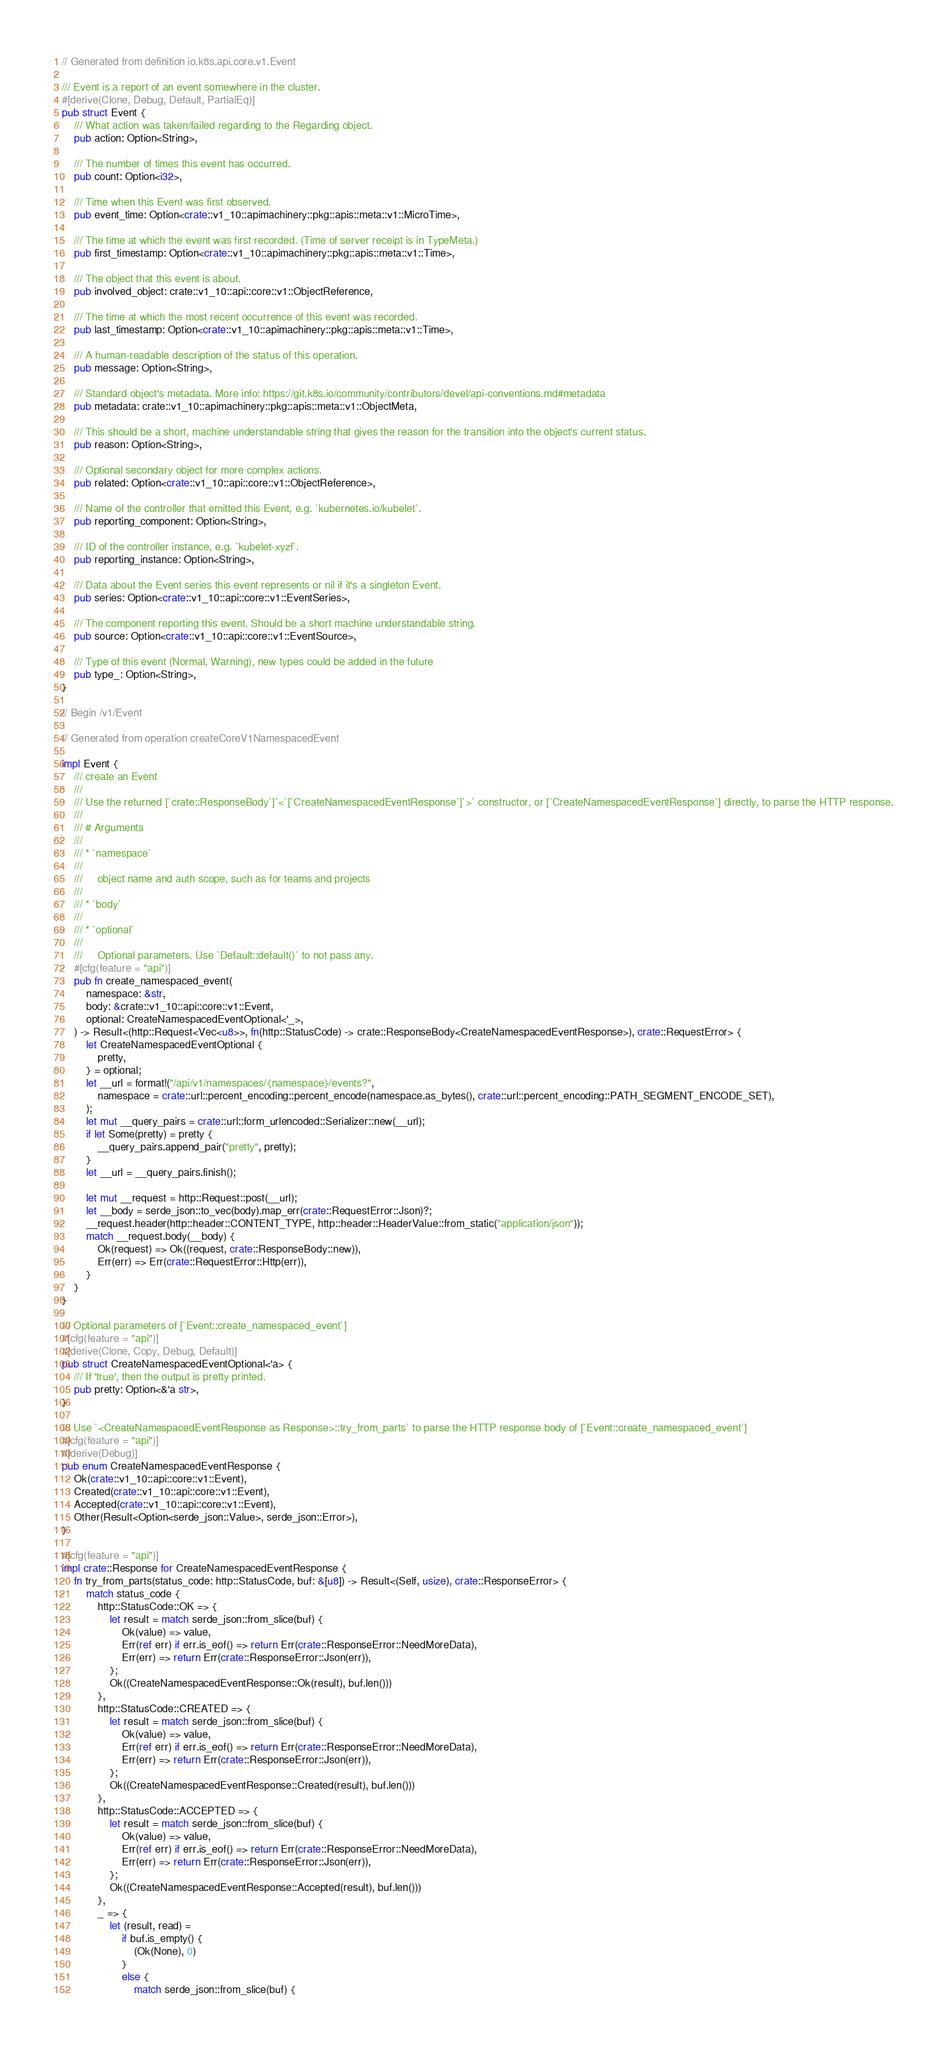<code> <loc_0><loc_0><loc_500><loc_500><_Rust_>// Generated from definition io.k8s.api.core.v1.Event

/// Event is a report of an event somewhere in the cluster.
#[derive(Clone, Debug, Default, PartialEq)]
pub struct Event {
    /// What action was taken/failed regarding to the Regarding object.
    pub action: Option<String>,

    /// The number of times this event has occurred.
    pub count: Option<i32>,

    /// Time when this Event was first observed.
    pub event_time: Option<crate::v1_10::apimachinery::pkg::apis::meta::v1::MicroTime>,

    /// The time at which the event was first recorded. (Time of server receipt is in TypeMeta.)
    pub first_timestamp: Option<crate::v1_10::apimachinery::pkg::apis::meta::v1::Time>,

    /// The object that this event is about.
    pub involved_object: crate::v1_10::api::core::v1::ObjectReference,

    /// The time at which the most recent occurrence of this event was recorded.
    pub last_timestamp: Option<crate::v1_10::apimachinery::pkg::apis::meta::v1::Time>,

    /// A human-readable description of the status of this operation.
    pub message: Option<String>,

    /// Standard object's metadata. More info: https://git.k8s.io/community/contributors/devel/api-conventions.md#metadata
    pub metadata: crate::v1_10::apimachinery::pkg::apis::meta::v1::ObjectMeta,

    /// This should be a short, machine understandable string that gives the reason for the transition into the object's current status.
    pub reason: Option<String>,

    /// Optional secondary object for more complex actions.
    pub related: Option<crate::v1_10::api::core::v1::ObjectReference>,

    /// Name of the controller that emitted this Event, e.g. `kubernetes.io/kubelet`.
    pub reporting_component: Option<String>,

    /// ID of the controller instance, e.g. `kubelet-xyzf`.
    pub reporting_instance: Option<String>,

    /// Data about the Event series this event represents or nil if it's a singleton Event.
    pub series: Option<crate::v1_10::api::core::v1::EventSeries>,

    /// The component reporting this event. Should be a short machine understandable string.
    pub source: Option<crate::v1_10::api::core::v1::EventSource>,

    /// Type of this event (Normal, Warning), new types could be added in the future
    pub type_: Option<String>,
}

// Begin /v1/Event

// Generated from operation createCoreV1NamespacedEvent

impl Event {
    /// create an Event
    ///
    /// Use the returned [`crate::ResponseBody`]`<`[`CreateNamespacedEventResponse`]`>` constructor, or [`CreateNamespacedEventResponse`] directly, to parse the HTTP response.
    ///
    /// # Arguments
    ///
    /// * `namespace`
    ///
    ///     object name and auth scope, such as for teams and projects
    ///
    /// * `body`
    ///
    /// * `optional`
    ///
    ///     Optional parameters. Use `Default::default()` to not pass any.
    #[cfg(feature = "api")]
    pub fn create_namespaced_event(
        namespace: &str,
        body: &crate::v1_10::api::core::v1::Event,
        optional: CreateNamespacedEventOptional<'_>,
    ) -> Result<(http::Request<Vec<u8>>, fn(http::StatusCode) -> crate::ResponseBody<CreateNamespacedEventResponse>), crate::RequestError> {
        let CreateNamespacedEventOptional {
            pretty,
        } = optional;
        let __url = format!("/api/v1/namespaces/{namespace}/events?",
            namespace = crate::url::percent_encoding::percent_encode(namespace.as_bytes(), crate::url::percent_encoding::PATH_SEGMENT_ENCODE_SET),
        );
        let mut __query_pairs = crate::url::form_urlencoded::Serializer::new(__url);
        if let Some(pretty) = pretty {
            __query_pairs.append_pair("pretty", pretty);
        }
        let __url = __query_pairs.finish();

        let mut __request = http::Request::post(__url);
        let __body = serde_json::to_vec(body).map_err(crate::RequestError::Json)?;
        __request.header(http::header::CONTENT_TYPE, http::header::HeaderValue::from_static("application/json"));
        match __request.body(__body) {
            Ok(request) => Ok((request, crate::ResponseBody::new)),
            Err(err) => Err(crate::RequestError::Http(err)),
        }
    }
}

/// Optional parameters of [`Event::create_namespaced_event`]
#[cfg(feature = "api")]
#[derive(Clone, Copy, Debug, Default)]
pub struct CreateNamespacedEventOptional<'a> {
    /// If 'true', then the output is pretty printed.
    pub pretty: Option<&'a str>,
}

/// Use `<CreateNamespacedEventResponse as Response>::try_from_parts` to parse the HTTP response body of [`Event::create_namespaced_event`]
#[cfg(feature = "api")]
#[derive(Debug)]
pub enum CreateNamespacedEventResponse {
    Ok(crate::v1_10::api::core::v1::Event),
    Created(crate::v1_10::api::core::v1::Event),
    Accepted(crate::v1_10::api::core::v1::Event),
    Other(Result<Option<serde_json::Value>, serde_json::Error>),
}

#[cfg(feature = "api")]
impl crate::Response for CreateNamespacedEventResponse {
    fn try_from_parts(status_code: http::StatusCode, buf: &[u8]) -> Result<(Self, usize), crate::ResponseError> {
        match status_code {
            http::StatusCode::OK => {
                let result = match serde_json::from_slice(buf) {
                    Ok(value) => value,
                    Err(ref err) if err.is_eof() => return Err(crate::ResponseError::NeedMoreData),
                    Err(err) => return Err(crate::ResponseError::Json(err)),
                };
                Ok((CreateNamespacedEventResponse::Ok(result), buf.len()))
            },
            http::StatusCode::CREATED => {
                let result = match serde_json::from_slice(buf) {
                    Ok(value) => value,
                    Err(ref err) if err.is_eof() => return Err(crate::ResponseError::NeedMoreData),
                    Err(err) => return Err(crate::ResponseError::Json(err)),
                };
                Ok((CreateNamespacedEventResponse::Created(result), buf.len()))
            },
            http::StatusCode::ACCEPTED => {
                let result = match serde_json::from_slice(buf) {
                    Ok(value) => value,
                    Err(ref err) if err.is_eof() => return Err(crate::ResponseError::NeedMoreData),
                    Err(err) => return Err(crate::ResponseError::Json(err)),
                };
                Ok((CreateNamespacedEventResponse::Accepted(result), buf.len()))
            },
            _ => {
                let (result, read) =
                    if buf.is_empty() {
                        (Ok(None), 0)
                    }
                    else {
                        match serde_json::from_slice(buf) {</code> 